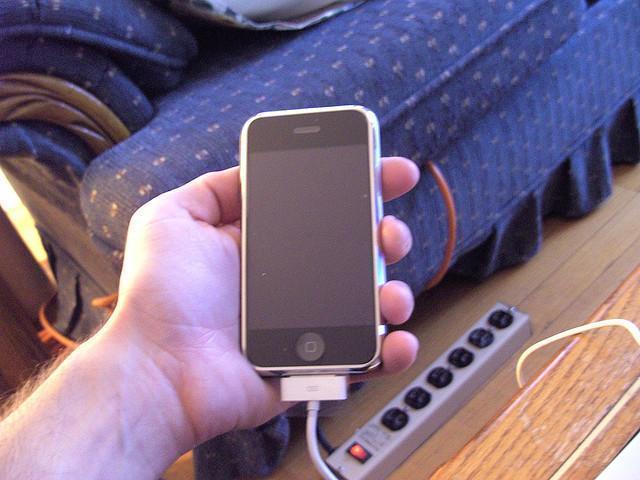What is the item on the floor called?
Indicate the correct response by choosing from the four available options to answer the question.
Options: Staple gun, machete, power strip, bolt cutter. Power strip. 